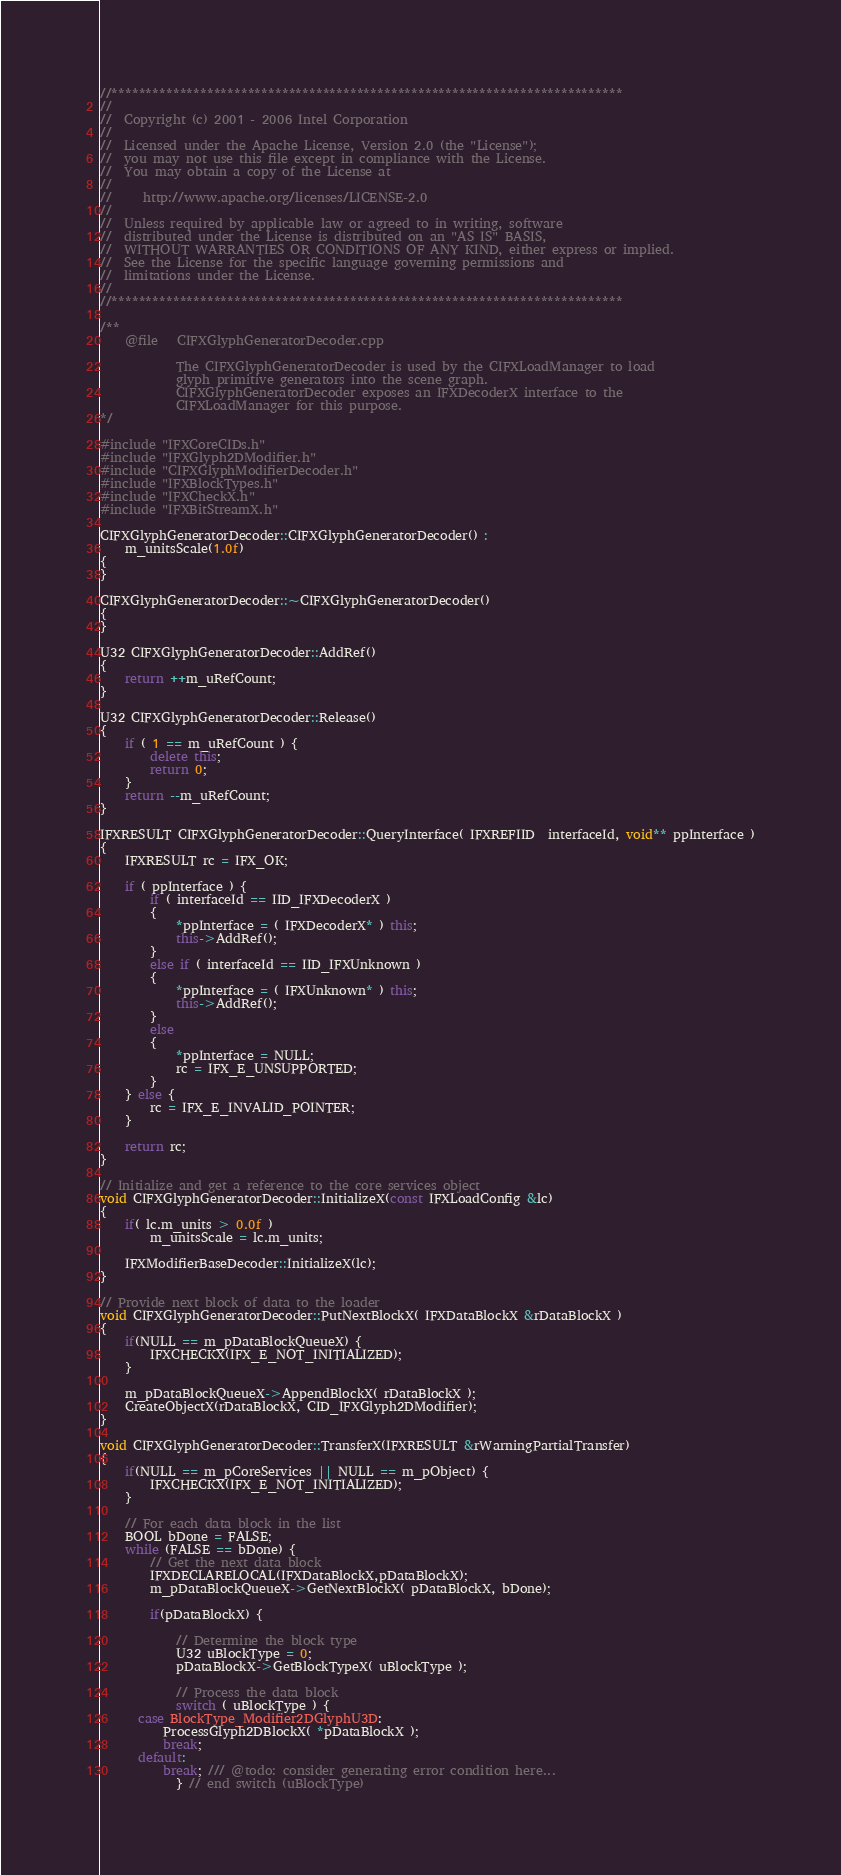<code> <loc_0><loc_0><loc_500><loc_500><_C++_>//***************************************************************************
//
//  Copyright (c) 2001 - 2006 Intel Corporation
//
//  Licensed under the Apache License, Version 2.0 (the "License");
//  you may not use this file except in compliance with the License.
//  You may obtain a copy of the License at
//
//     http://www.apache.org/licenses/LICENSE-2.0
//
//  Unless required by applicable law or agreed to in writing, software
//  distributed under the License is distributed on an "AS IS" BASIS,
//  WITHOUT WARRANTIES OR CONDITIONS OF ANY KIND, either express or implied.
//  See the License for the specific language governing permissions and
//  limitations under the License.
//
//***************************************************************************

/**
	@file	CIFXGlyphGeneratorDecoder.cpp

			The CIFXGlyphGeneratorDecoder is used by the CIFXLoadManager to load
			glyph primitive generators into the scene graph.
			CIFXGlyphGeneratorDecoder exposes an IFXDecoderX interface to the
			CIFXLoadManager for this purpose.
*/

#include "IFXCoreCIDs.h"
#include "IFXGlyph2DModifier.h"
#include "CIFXGlyphModifierDecoder.h"
#include "IFXBlockTypes.h"
#include "IFXCheckX.h"
#include "IFXBitStreamX.h"

CIFXGlyphGeneratorDecoder::CIFXGlyphGeneratorDecoder() :
	m_unitsScale(1.0f)
{
}

CIFXGlyphGeneratorDecoder::~CIFXGlyphGeneratorDecoder()
{
}

U32 CIFXGlyphGeneratorDecoder::AddRef()
{
	return ++m_uRefCount;
}

U32 CIFXGlyphGeneratorDecoder::Release()
{
	if ( 1 == m_uRefCount ) {
		delete this;
		return 0;
	}
	return --m_uRefCount;
}

IFXRESULT CIFXGlyphGeneratorDecoder::QueryInterface( IFXREFIID  interfaceId, void** ppInterface )
{
	IFXRESULT rc = IFX_OK;

	if ( ppInterface ) {
		if ( interfaceId == IID_IFXDecoderX )
		{
			*ppInterface = ( IFXDecoderX* ) this;
			this->AddRef();
		}
		else if ( interfaceId == IID_IFXUnknown )
		{
			*ppInterface = ( IFXUnknown* ) this;
			this->AddRef();
		}
		else
		{
			*ppInterface = NULL;
			rc = IFX_E_UNSUPPORTED;
		}
	} else {
		rc = IFX_E_INVALID_POINTER;
	}

	return rc;
}

// Initialize and get a reference to the core services object
void CIFXGlyphGeneratorDecoder::InitializeX(const IFXLoadConfig &lc)
{
	if( lc.m_units > 0.0f )
		m_unitsScale = lc.m_units;

	IFXModifierBaseDecoder::InitializeX(lc);
}

// Provide next block of data to the loader
void CIFXGlyphGeneratorDecoder::PutNextBlockX( IFXDataBlockX &rDataBlockX )
{
	if(NULL == m_pDataBlockQueueX) {
		IFXCHECKX(IFX_E_NOT_INITIALIZED);
	}

	m_pDataBlockQueueX->AppendBlockX( rDataBlockX );
	CreateObjectX(rDataBlockX, CID_IFXGlyph2DModifier);
}

void CIFXGlyphGeneratorDecoder::TransferX(IFXRESULT &rWarningPartialTransfer)
{
	if(NULL == m_pCoreServices || NULL == m_pObject) {
		IFXCHECKX(IFX_E_NOT_INITIALIZED);
	}

	// For each data block in the list
	BOOL bDone = FALSE;
	while (FALSE == bDone) {
		// Get the next data block
		IFXDECLARELOCAL(IFXDataBlockX,pDataBlockX);
		m_pDataBlockQueueX->GetNextBlockX( pDataBlockX, bDone);

		if(pDataBlockX) {

			// Determine the block type
			U32 uBlockType = 0;
			pDataBlockX->GetBlockTypeX( uBlockType );

			// Process the data block
			switch ( uBlockType ) {
	  case BlockType_Modifier2DGlyphU3D:
		  ProcessGlyph2DBlockX( *pDataBlockX );
		  break;
	  default:
		  break; /// @todo: consider generating error condition here...
			} // end switch (uBlockType)
</code> 